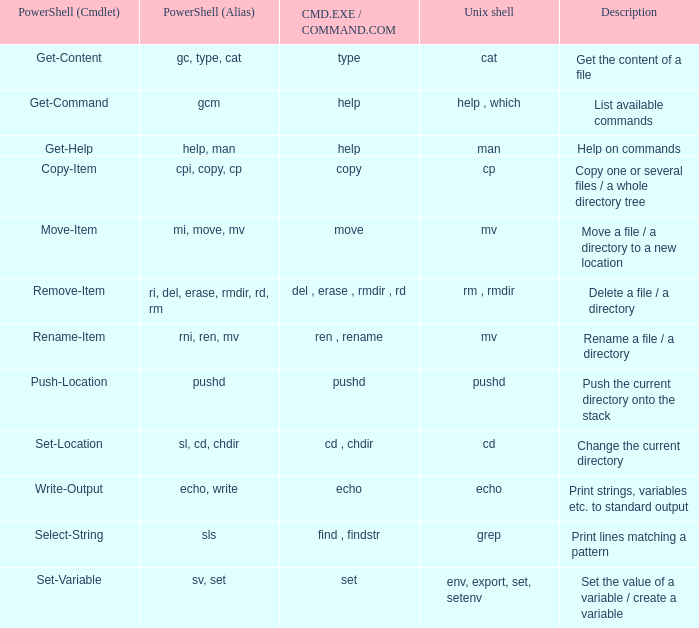How many valid values of powershell (cmdlet) are there when unix shell includes env, export, set, and setenv? 1.0. 